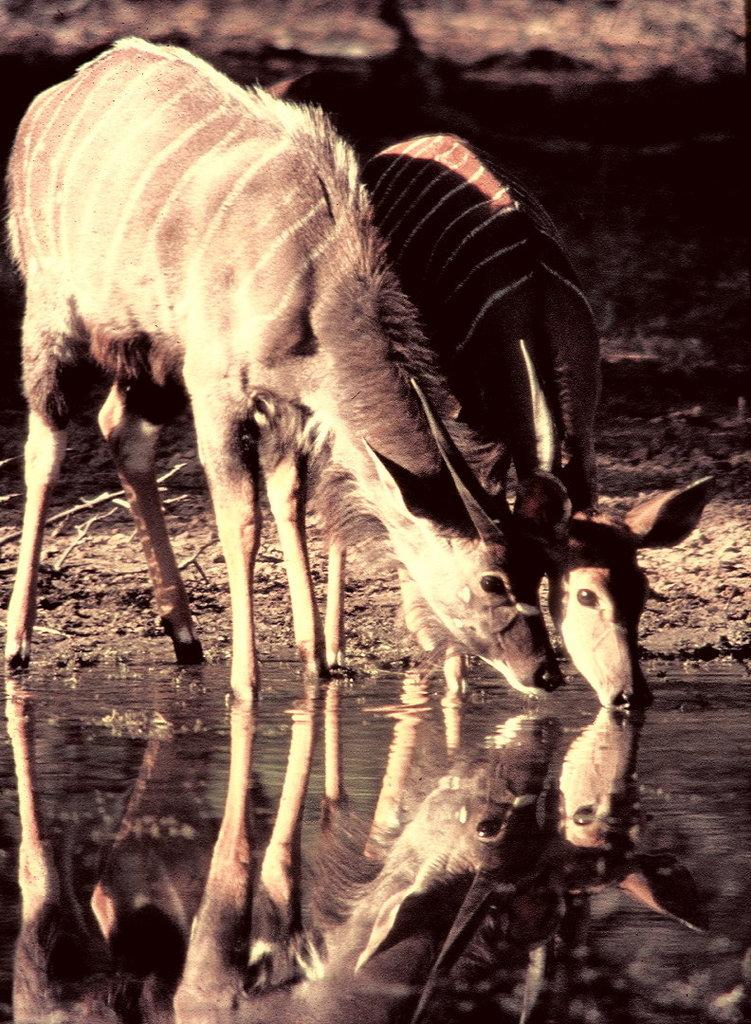What animals can be seen in the foreground of the image? There are two deer in the foreground of the image. What type of terrain is visible at the bottom of the image? There is water visible at the bottom of the image. What type of terrain is visible at the top of the image? There is land visible at the top of the image. What type of cup is being used by the deer in the image? There is no cup present in the image, as the deer are in a natural setting and not using any human-made objects. 